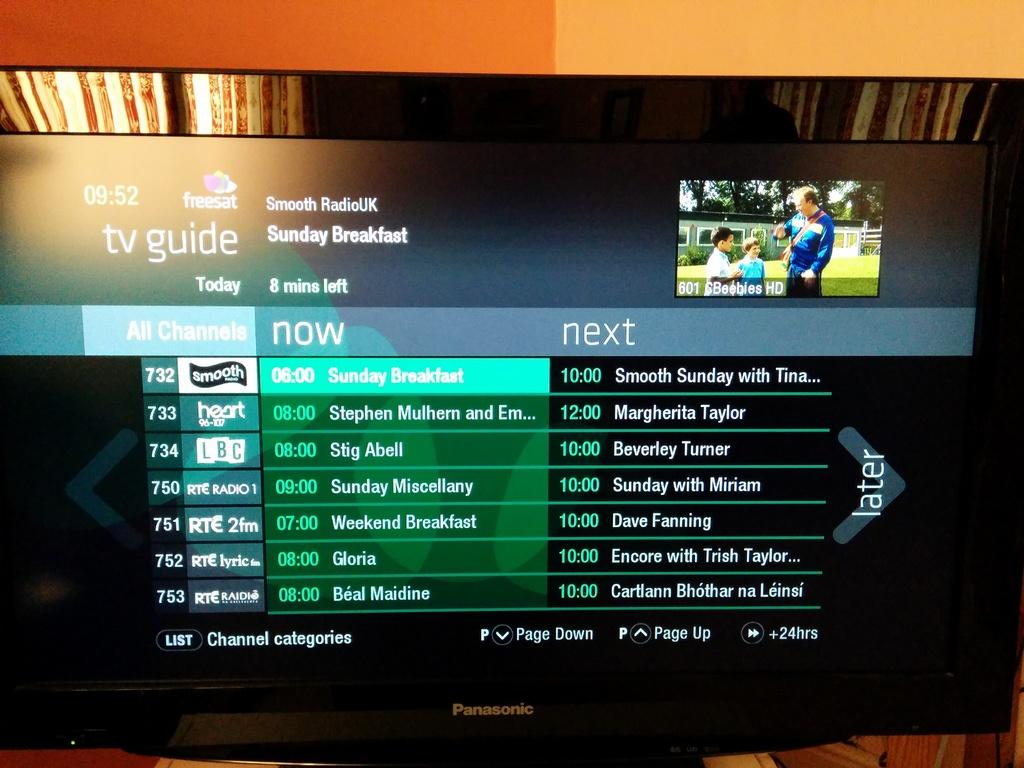<image>
Provide a brief description of the given image. A screen displays a TV guide for several channels, including 732. 